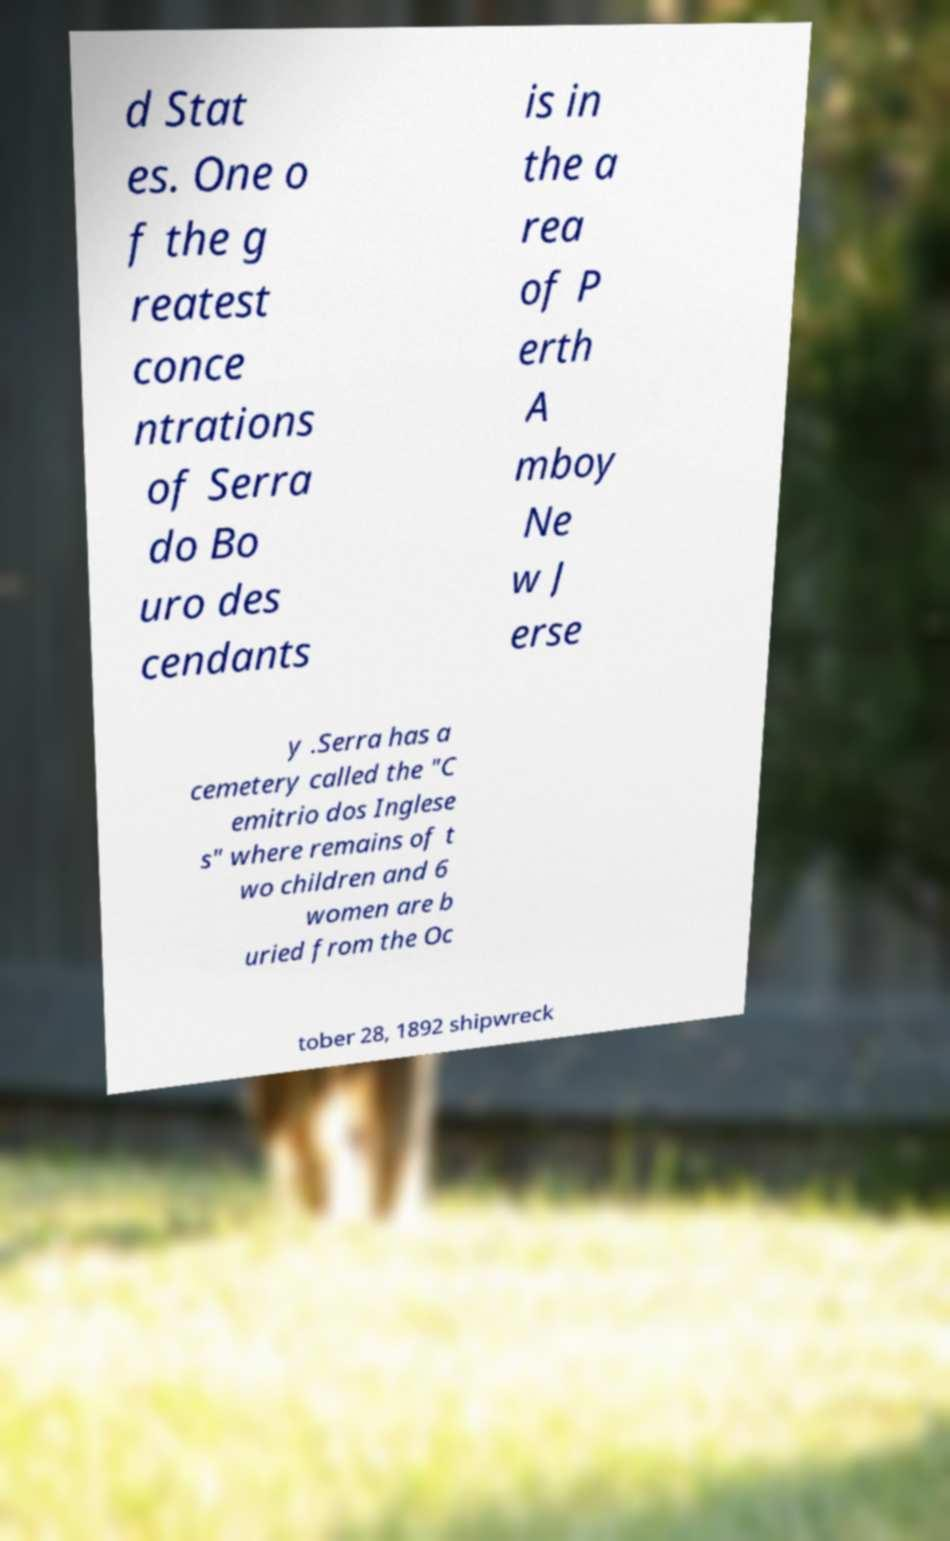Could you extract and type out the text from this image? d Stat es. One o f the g reatest conce ntrations of Serra do Bo uro des cendants is in the a rea of P erth A mboy Ne w J erse y .Serra has a cemetery called the "C emitrio dos Inglese s" where remains of t wo children and 6 women are b uried from the Oc tober 28, 1892 shipwreck 